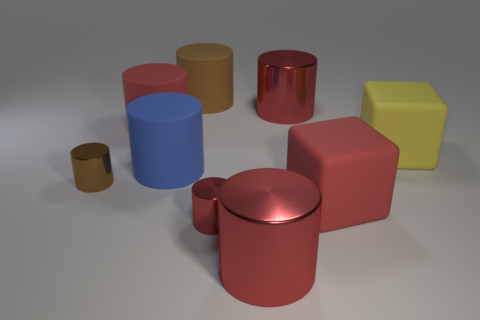What shape is the big yellow object?
Provide a succinct answer. Cube. There is a small cylinder that is on the right side of the brown shiny cylinder; what is it made of?
Give a very brief answer. Metal. What is the color of the tiny metal thing that is left of the object that is behind the large shiny object that is behind the small brown object?
Offer a very short reply. Brown. There is a cube that is the same size as the yellow object; what is its color?
Provide a succinct answer. Red. What number of metal things are either yellow blocks or tiny blue cubes?
Your response must be concise. 0. What color is the other cube that is the same material as the red block?
Ensure brevity in your answer.  Yellow. What material is the big red cylinder on the left side of the rubber object behind the red rubber cylinder?
Offer a terse response. Rubber. What number of objects are things on the left side of the tiny red cylinder or big red cylinders that are in front of the small red metal object?
Keep it short and to the point. 5. How big is the red matte object that is in front of the cylinder to the left of the large red rubber cylinder that is behind the large blue cylinder?
Ensure brevity in your answer.  Large. Is the number of brown cylinders that are on the right side of the small red cylinder the same as the number of brown cylinders?
Your response must be concise. No. 